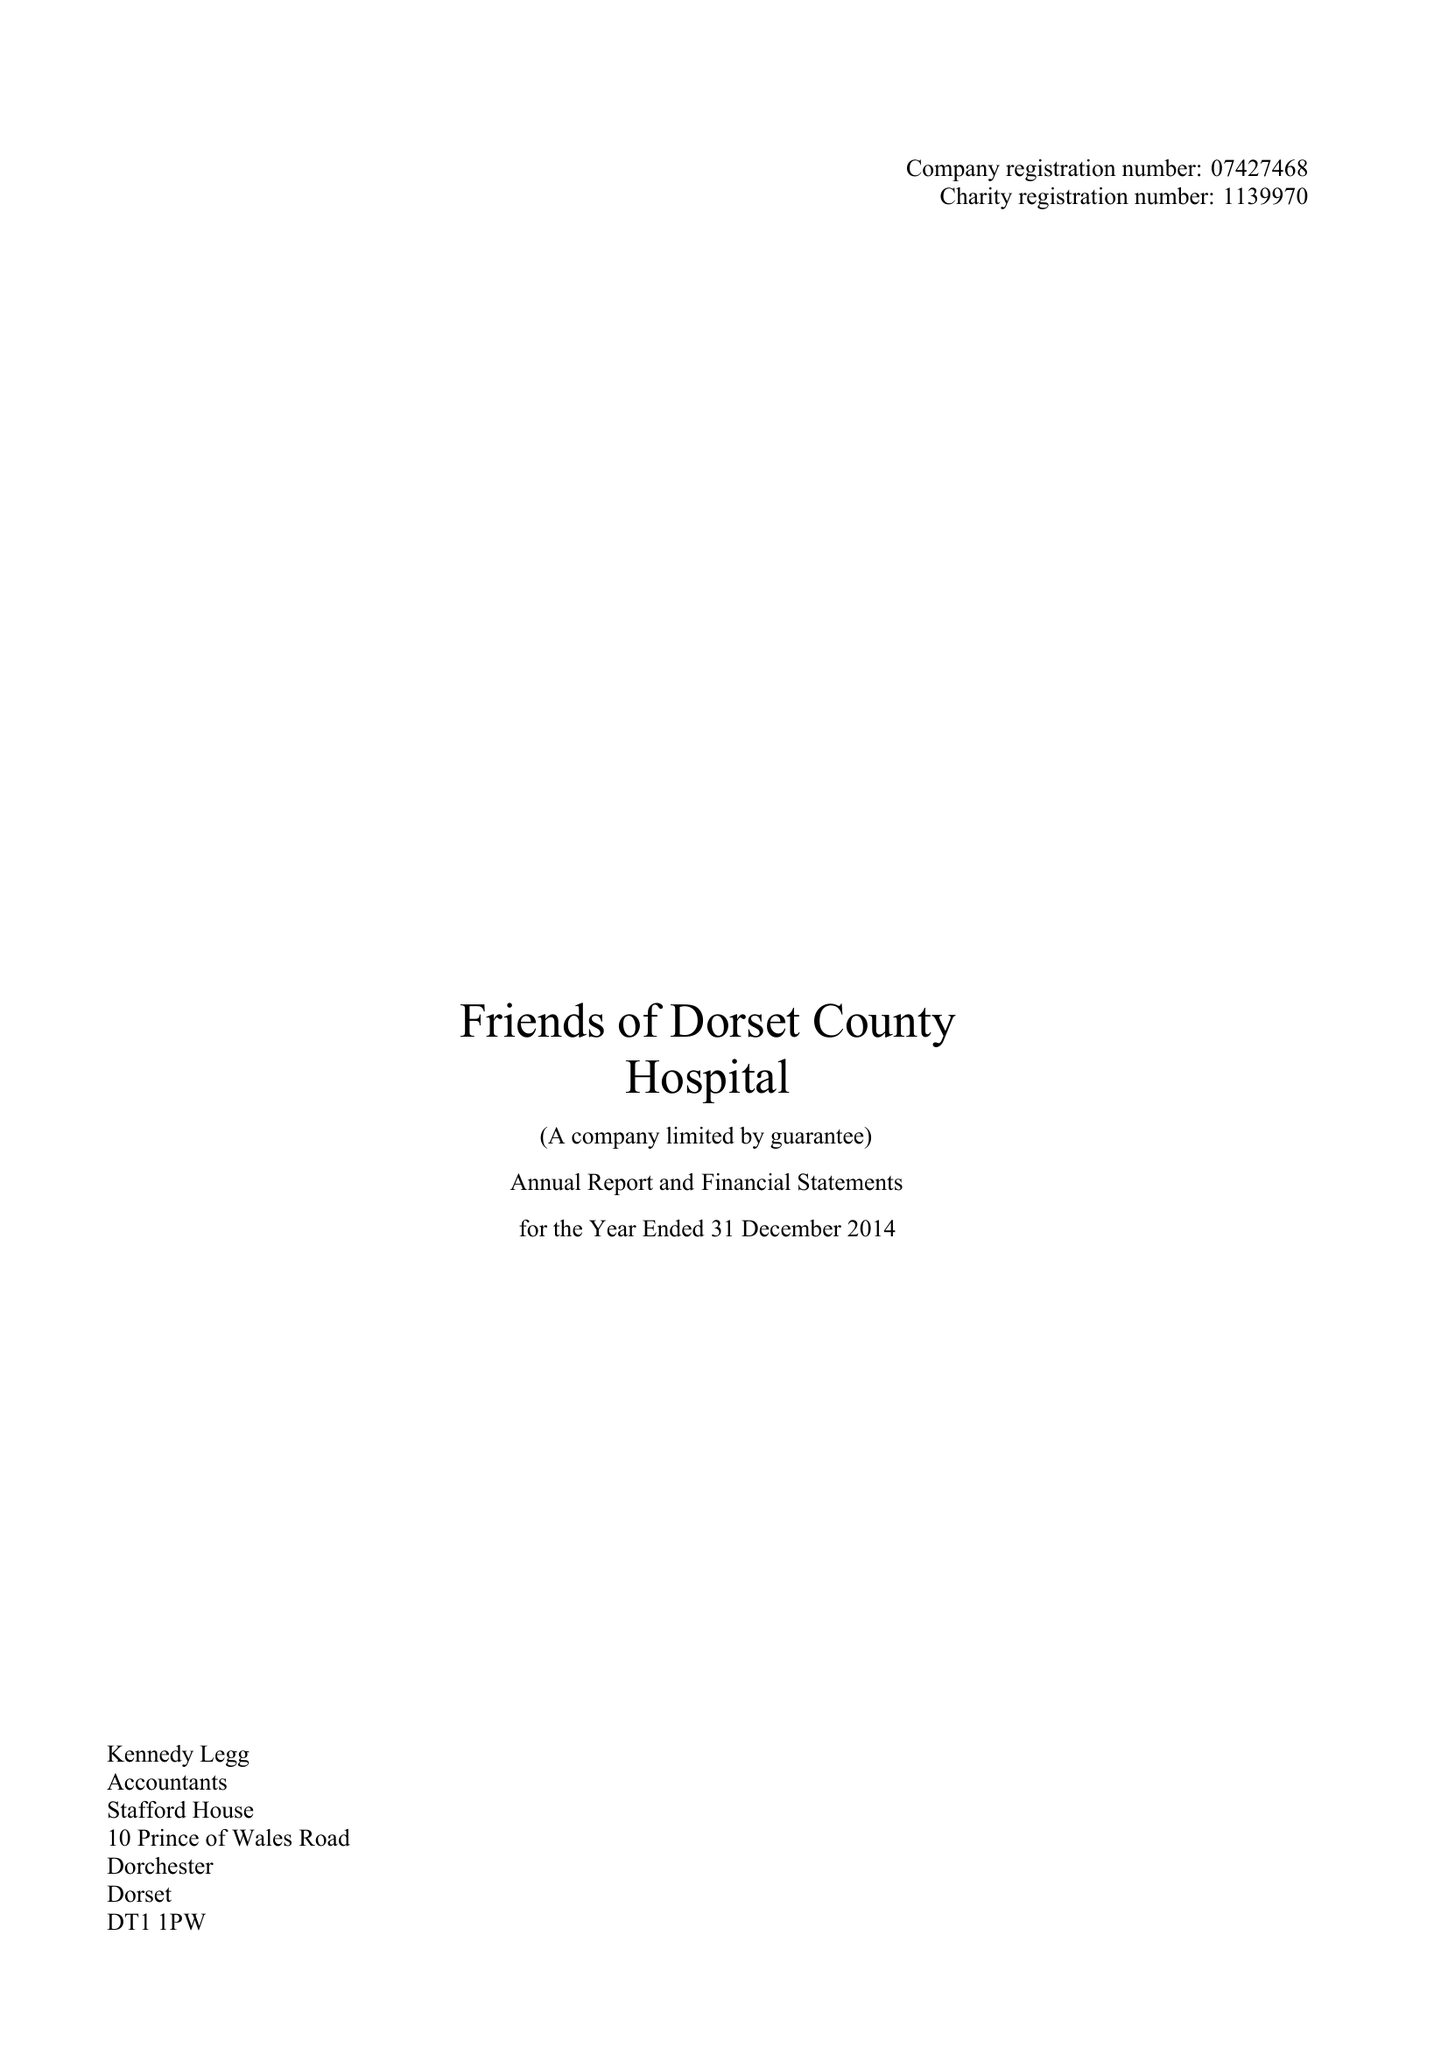What is the value for the address__post_town?
Answer the question using a single word or phrase. DORCHESTER 